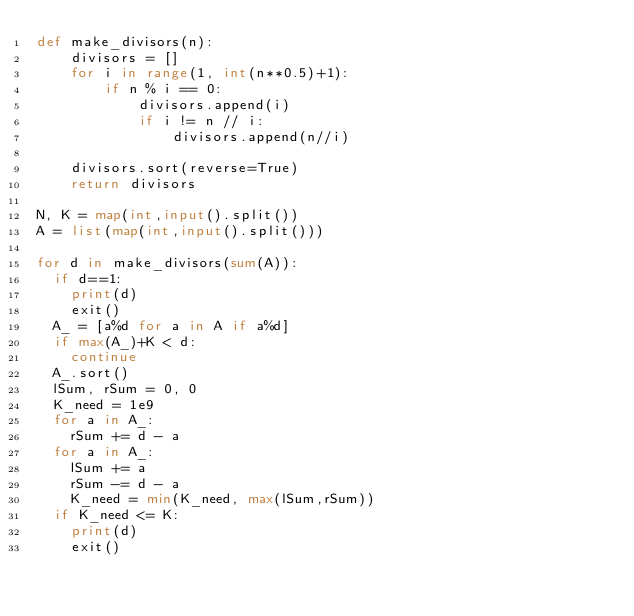Convert code to text. <code><loc_0><loc_0><loc_500><loc_500><_Python_>def make_divisors(n):
    divisors = []
    for i in range(1, int(n**0.5)+1):
        if n % i == 0:
            divisors.append(i)
            if i != n // i:
                divisors.append(n//i)

    divisors.sort(reverse=True)
    return divisors

N, K = map(int,input().split())
A = list(map(int,input().split()))

for d in make_divisors(sum(A)):
  if d==1:
    print(d)
    exit()
  A_ = [a%d for a in A if a%d]
  if max(A_)+K < d:
    continue  
  A_.sort()
  lSum, rSum = 0, 0
  K_need = 1e9
  for a in A_:
    rSum += d - a
  for a in A_:
    lSum += a
    rSum -= d - a
    K_need = min(K_need, max(lSum,rSum))
  if K_need <= K:
    print(d)
    exit()
  </code> 